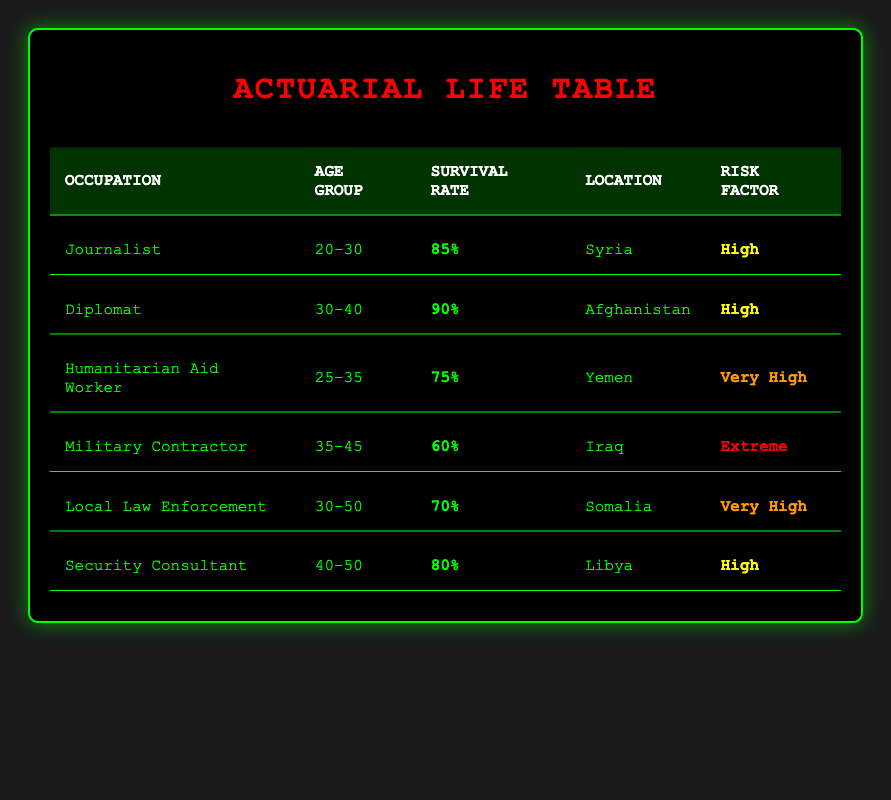What is the survival rate for journalists working in Syria? The table lists the survival rate for journalists under the "Survival Rate" column and identifies their location as Syria in the "Location" column. The corresponding survival rate is 85%.
Answer: 85% Which occupation has the lowest survival rate? To find the lowest survival rate, I need to compare the survival rates from all the occupations listed in the table. The rates are 85%, 90%, 75%, 60%, 70%, and 80%. The lowest rate is 60%, which belongs to the "Military Contractor."
Answer: Military Contractor Are humanitarian aid workers at higher risk than security consultants? The risk factor for "Humanitarian Aid Worker" is "Very High," while for "Security Consultant," it is "High." Since "Very High" indicates a higher risk than "High," the answer is yes.
Answer: Yes What is the average survival rate for the occupations listed? The survival rates are 85%, 90%, 75%, 60%, 70%, and 80%. First, I sum these values: 85 + 90 + 75 + 60 + 70 + 80 = 460. Then, I divide by the number of occupations (6): 460 / 6 = 76.67. Therefore, the average survival rate is approximately 76.67%.
Answer: 76.67% Is the survival rate for local law enforcement higher than that for military contractors? The survival rate for "Local Law Enforcement" is 70%, while for "Military Contractor" it is 60%. Since 70% is greater than 60%, the answer is yes.
Answer: Yes Which occupations are categorized as having an extreme risk factor? By looking at the "Risk Factor" column, I see that the only occupation with an "Extreme" risk factor is "Military Contractor." Therefore, there is only one occupation that fits this category.
Answer: Military Contractor How many occupations have a survival rate of 70% or higher? The survival rates that are 70% or higher are: 85%, 90%, 75%, 70%, and 80%, totaling five occupations— "Journalist," "Diplomat," "Humanitarian Aid Worker," "Local Law Enforcement," and "Security Consultant."
Answer: 5 What is the location of the occupation with the highest survival rate? The occupation with the highest survival rate is "Diplomat" with a survival rate of 90%. The "Location" column states that this occupation is in Afghanistan. Thus, the location for the highest survival rate is Afghanistan.
Answer: Afghanistan Are all occupations listed in the table based in countries considered as terrorism hotspots? The table lists occupations in Syria, Afghanistan, Yemen, Iraq, Somalia, and Libya. Each of these countries is commonly recognized as a terrorism hotspot, so the answer is yes.
Answer: Yes 